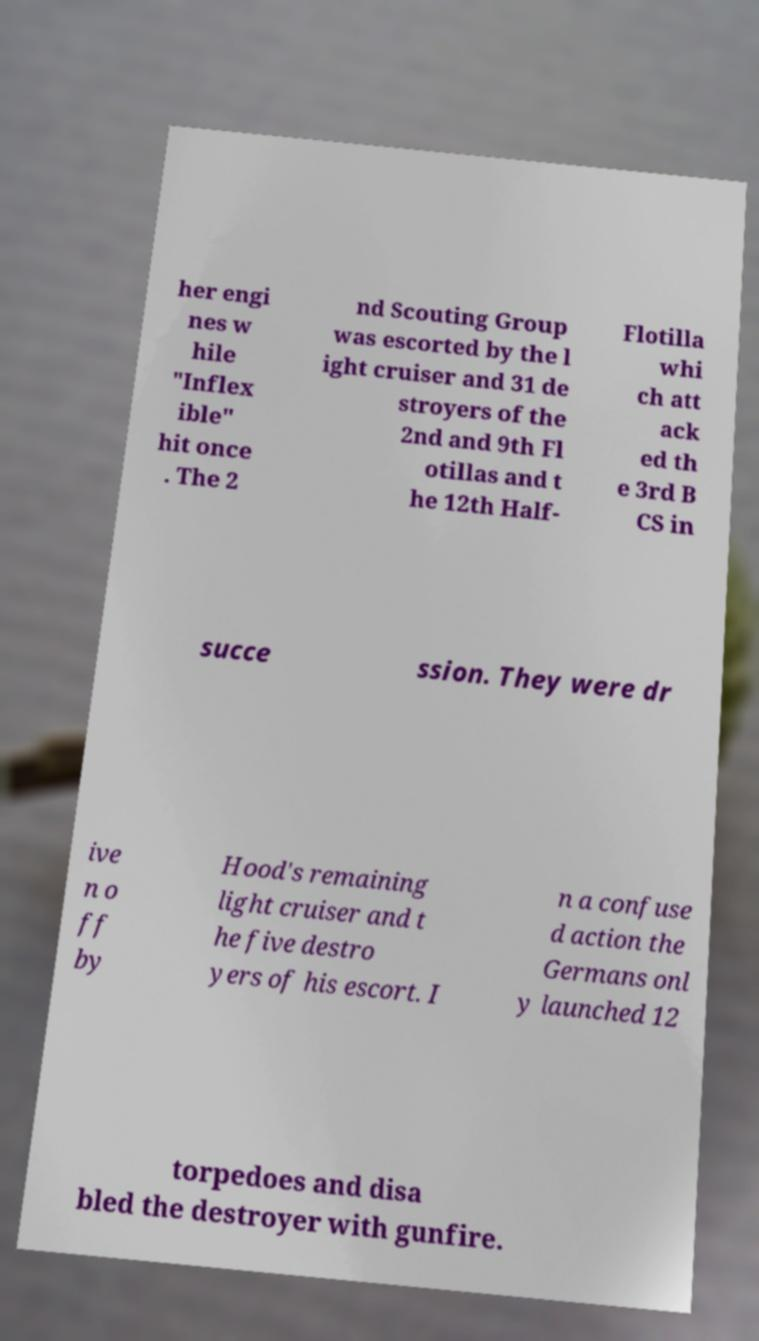What messages or text are displayed in this image? I need them in a readable, typed format. her engi nes w hile "Inflex ible" hit once . The 2 nd Scouting Group was escorted by the l ight cruiser and 31 de stroyers of the 2nd and 9th Fl otillas and t he 12th Half- Flotilla whi ch att ack ed th e 3rd B CS in succe ssion. They were dr ive n o ff by Hood's remaining light cruiser and t he five destro yers of his escort. I n a confuse d action the Germans onl y launched 12 torpedoes and disa bled the destroyer with gunfire. 